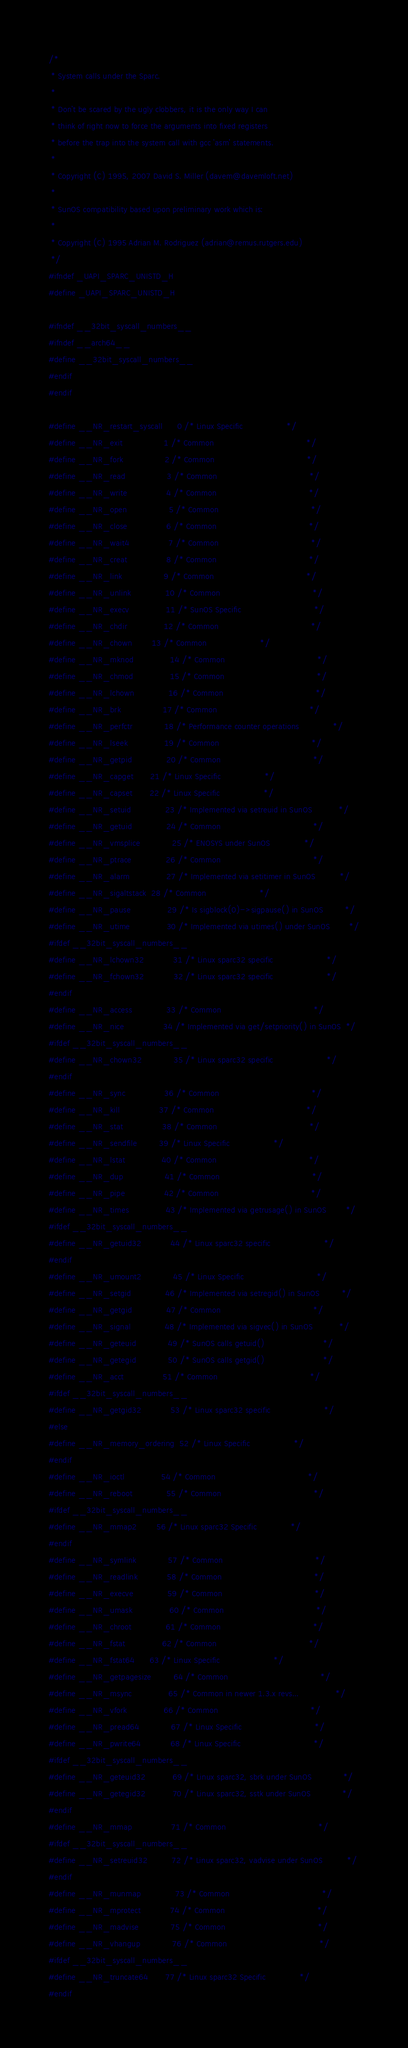Convert code to text. <code><loc_0><loc_0><loc_500><loc_500><_C_>/*
 * System calls under the Sparc.
 *
 * Don't be scared by the ugly clobbers, it is the only way I can
 * think of right now to force the arguments into fixed registers
 * before the trap into the system call with gcc 'asm' statements.
 *
 * Copyright (C) 1995, 2007 David S. Miller (davem@davemloft.net)
 *
 * SunOS compatibility based upon preliminary work which is:
 *
 * Copyright (C) 1995 Adrian M. Rodriguez (adrian@remus.rutgers.edu)
 */
#ifndef _UAPI_SPARC_UNISTD_H
#define _UAPI_SPARC_UNISTD_H

#ifndef __32bit_syscall_numbers__
#ifndef __arch64__
#define __32bit_syscall_numbers__
#endif
#endif

#define __NR_restart_syscall      0 /* Linux Specific				   */
#define __NR_exit                 1 /* Common                                      */
#define __NR_fork                 2 /* Common                                      */
#define __NR_read                 3 /* Common                                      */
#define __NR_write                4 /* Common                                      */
#define __NR_open                 5 /* Common                                      */
#define __NR_close                6 /* Common                                      */
#define __NR_wait4                7 /* Common                                      */
#define __NR_creat                8 /* Common                                      */
#define __NR_link                 9 /* Common                                      */
#define __NR_unlink              10 /* Common                                      */
#define __NR_execv               11 /* SunOS Specific                              */
#define __NR_chdir               12 /* Common                                      */
#define __NR_chown		 13 /* Common					   */
#define __NR_mknod               14 /* Common                                      */
#define __NR_chmod               15 /* Common                                      */
#define __NR_lchown              16 /* Common                                      */
#define __NR_brk                 17 /* Common                                      */
#define __NR_perfctr             18 /* Performance counter operations              */
#define __NR_lseek               19 /* Common                                      */
#define __NR_getpid              20 /* Common                                      */
#define __NR_capget		 21 /* Linux Specific				   */
#define __NR_capset		 22 /* Linux Specific				   */
#define __NR_setuid              23 /* Implemented via setreuid in SunOS           */
#define __NR_getuid              24 /* Common                                      */
#define __NR_vmsplice	         25 /* ENOSYS under SunOS			   */
#define __NR_ptrace              26 /* Common                                      */
#define __NR_alarm               27 /* Implemented via setitimer in SunOS          */
#define __NR_sigaltstack	 28 /* Common					   */
#define __NR_pause               29 /* Is sigblock(0)->sigpause() in SunOS         */
#define __NR_utime               30 /* Implemented via utimes() under SunOS        */
#ifdef __32bit_syscall_numbers__
#define __NR_lchown32            31 /* Linux sparc32 specific                      */
#define __NR_fchown32            32 /* Linux sparc32 specific                      */
#endif
#define __NR_access              33 /* Common                                      */
#define __NR_nice                34 /* Implemented via get/setpriority() in SunOS  */
#ifdef __32bit_syscall_numbers__
#define __NR_chown32             35 /* Linux sparc32 specific                      */
#endif
#define __NR_sync                36 /* Common                                      */
#define __NR_kill                37 /* Common                                      */
#define __NR_stat                38 /* Common                                      */
#define __NR_sendfile		 39 /* Linux Specific				   */
#define __NR_lstat               40 /* Common                                      */
#define __NR_dup                 41 /* Common                                      */
#define __NR_pipe                42 /* Common                                      */
#define __NR_times               43 /* Implemented via getrusage() in SunOS        */
#ifdef __32bit_syscall_numbers__
#define __NR_getuid32            44 /* Linux sparc32 specific                      */
#endif
#define __NR_umount2             45 /* Linux Specific                              */
#define __NR_setgid              46 /* Implemented via setregid() in SunOS         */
#define __NR_getgid              47 /* Common                                      */
#define __NR_signal              48 /* Implemented via sigvec() in SunOS           */
#define __NR_geteuid             49 /* SunOS calls getuid()                        */
#define __NR_getegid             50 /* SunOS calls getgid()                        */
#define __NR_acct                51 /* Common                                      */
#ifdef __32bit_syscall_numbers__
#define __NR_getgid32            53 /* Linux sparc32 specific                      */
#else
#define __NR_memory_ordering	 52 /* Linux Specific				   */
#endif
#define __NR_ioctl               54 /* Common                                      */
#define __NR_reboot              55 /* Common                                      */
#ifdef __32bit_syscall_numbers__
#define __NR_mmap2		 56 /* Linux sparc32 Specific			   */
#endif
#define __NR_symlink             57 /* Common                                      */
#define __NR_readlink            58 /* Common                                      */
#define __NR_execve              59 /* Common                                      */
#define __NR_umask               60 /* Common                                      */
#define __NR_chroot              61 /* Common                                      */
#define __NR_fstat               62 /* Common                                      */
#define __NR_fstat64		 63 /* Linux Specific			           */
#define __NR_getpagesize         64 /* Common                                      */
#define __NR_msync               65 /* Common in newer 1.3.x revs...               */
#define __NR_vfork               66 /* Common                                      */
#define __NR_pread64             67 /* Linux Specific                              */
#define __NR_pwrite64            68 /* Linux Specific                              */
#ifdef __32bit_syscall_numbers__
#define __NR_geteuid32           69 /* Linux sparc32, sbrk under SunOS             */
#define __NR_getegid32           70 /* Linux sparc32, sstk under SunOS             */
#endif
#define __NR_mmap                71 /* Common                                      */
#ifdef __32bit_syscall_numbers__
#define __NR_setreuid32          72 /* Linux sparc32, vadvise under SunOS          */
#endif
#define __NR_munmap              73 /* Common                                      */
#define __NR_mprotect            74 /* Common                                      */
#define __NR_madvise             75 /* Common                                      */
#define __NR_vhangup             76 /* Common                                      */
#ifdef __32bit_syscall_numbers__
#define __NR_truncate64		 77 /* Linux sparc32 Specific			   */
#endif</code> 